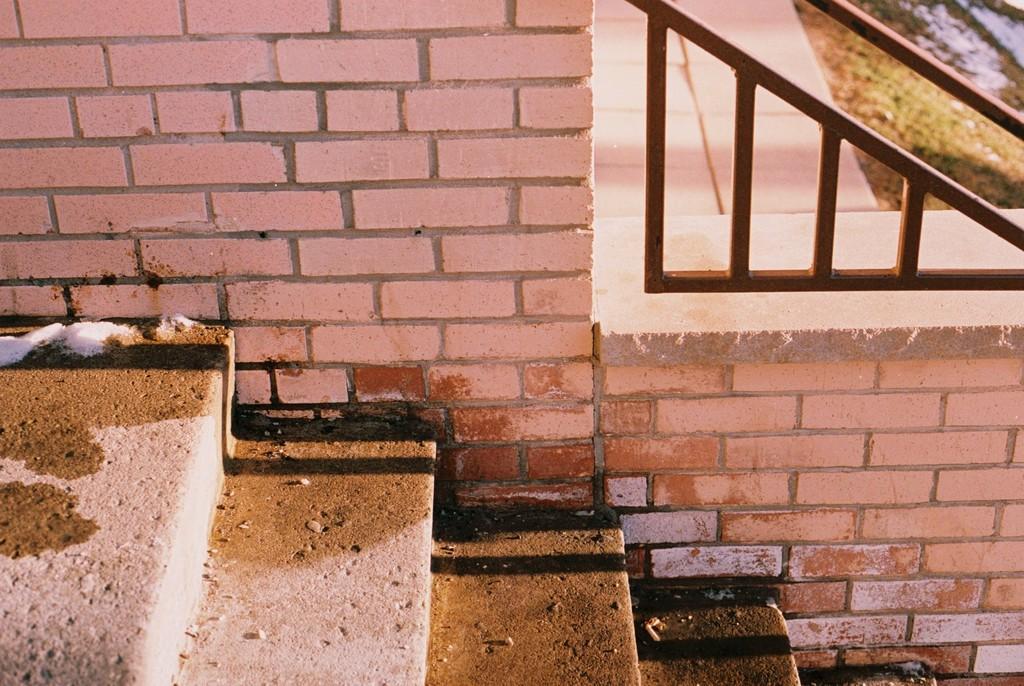How would you summarize this image in a sentence or two? In this image we can see the brick wall, stairs and we can also see the railing. 